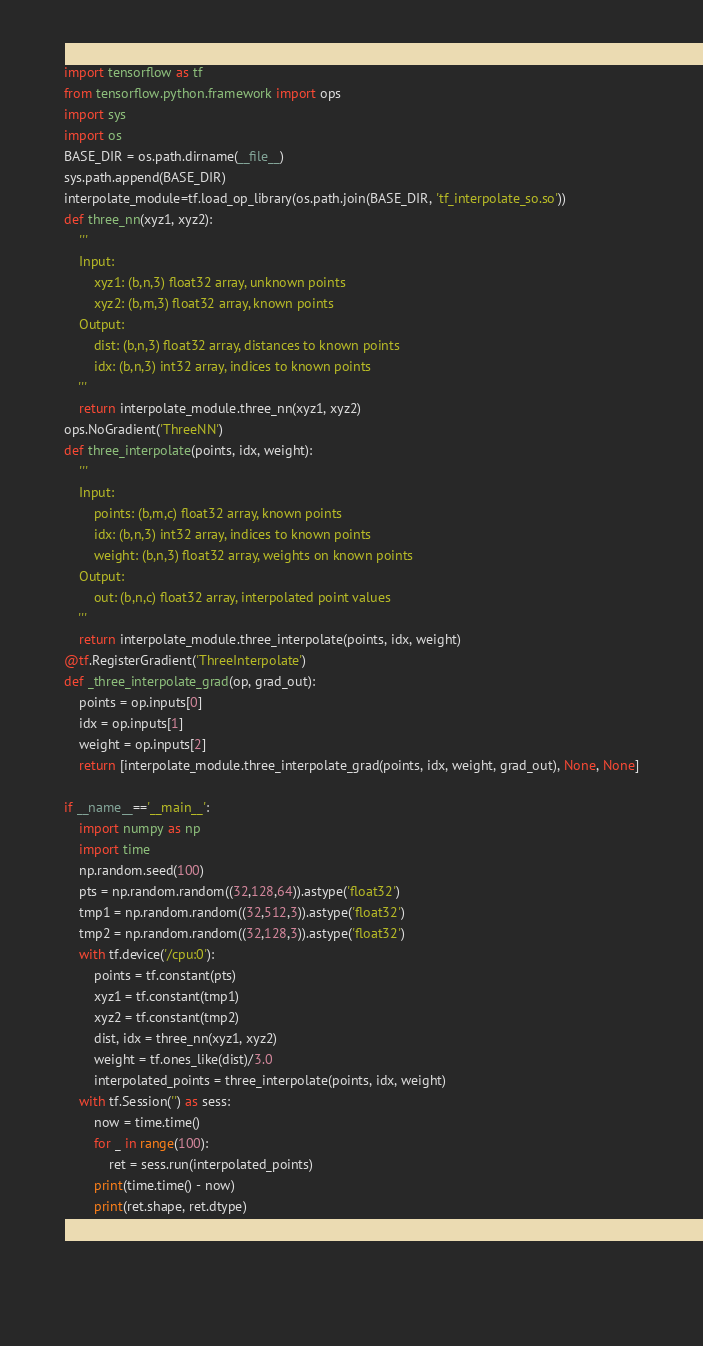Convert code to text. <code><loc_0><loc_0><loc_500><loc_500><_Python_>import tensorflow as tf
from tensorflow.python.framework import ops
import sys
import os
BASE_DIR = os.path.dirname(__file__)
sys.path.append(BASE_DIR)
interpolate_module=tf.load_op_library(os.path.join(BASE_DIR, 'tf_interpolate_so.so'))
def three_nn(xyz1, xyz2):
    '''
    Input:
        xyz1: (b,n,3) float32 array, unknown points
        xyz2: (b,m,3) float32 array, known points
    Output:
        dist: (b,n,3) float32 array, distances to known points
        idx: (b,n,3) int32 array, indices to known points
    '''
    return interpolate_module.three_nn(xyz1, xyz2)
ops.NoGradient('ThreeNN')
def three_interpolate(points, idx, weight):
    '''
    Input:
        points: (b,m,c) float32 array, known points
        idx: (b,n,3) int32 array, indices to known points
        weight: (b,n,3) float32 array, weights on known points
    Output:
        out: (b,n,c) float32 array, interpolated point values
    '''
    return interpolate_module.three_interpolate(points, idx, weight)
@tf.RegisterGradient('ThreeInterpolate')
def _three_interpolate_grad(op, grad_out):
    points = op.inputs[0]
    idx = op.inputs[1]
    weight = op.inputs[2]
    return [interpolate_module.three_interpolate_grad(points, idx, weight, grad_out), None, None]

if __name__=='__main__':
    import numpy as np
    import time
    np.random.seed(100)
    pts = np.random.random((32,128,64)).astype('float32')
    tmp1 = np.random.random((32,512,3)).astype('float32')
    tmp2 = np.random.random((32,128,3)).astype('float32')
    with tf.device('/cpu:0'):
        points = tf.constant(pts)
        xyz1 = tf.constant(tmp1)
        xyz2 = tf.constant(tmp2)
        dist, idx = three_nn(xyz1, xyz2)
        weight = tf.ones_like(dist)/3.0
        interpolated_points = three_interpolate(points, idx, weight)
    with tf.Session('') as sess:
        now = time.time() 
        for _ in range(100):
            ret = sess.run(interpolated_points)
        print(time.time() - now)
        print(ret.shape, ret.dtype)
    
    
    
</code> 